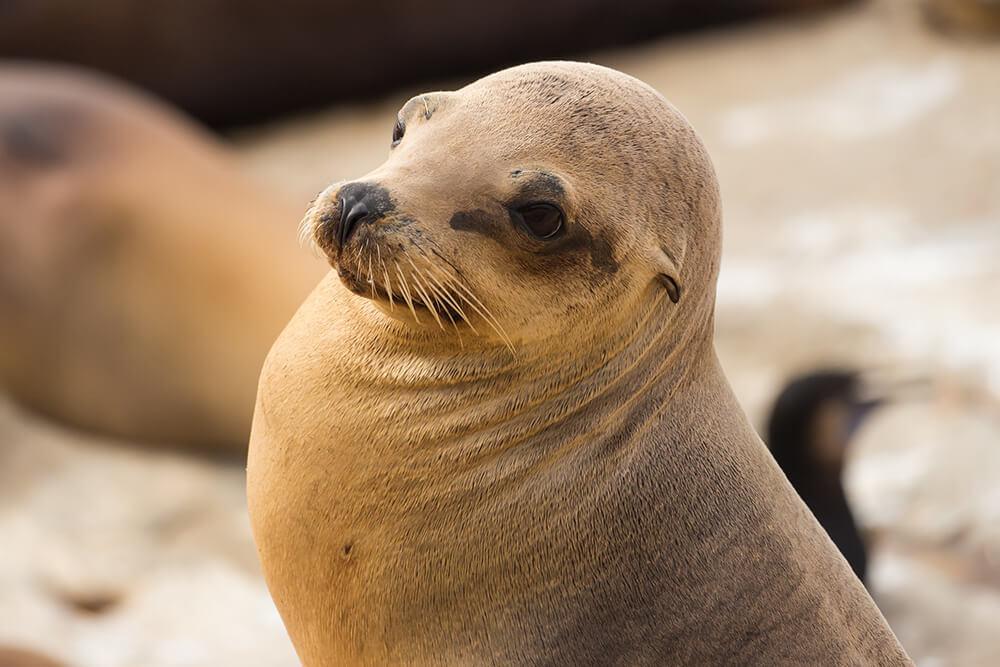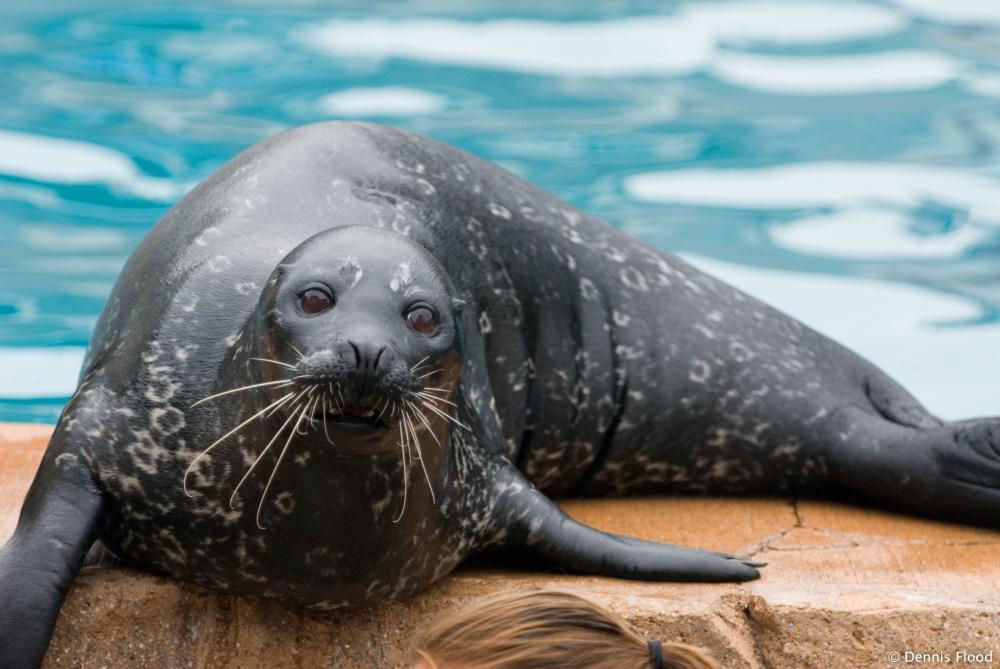The first image is the image on the left, the second image is the image on the right. Assess this claim about the two images: "An image shows only one seal in close-up, with its head cocked at an angle to the right.". Correct or not? Answer yes or no. Yes. The first image is the image on the left, the second image is the image on the right. Examine the images to the left and right. Is the description "There is water in the image on the left." accurate? Answer yes or no. No. 